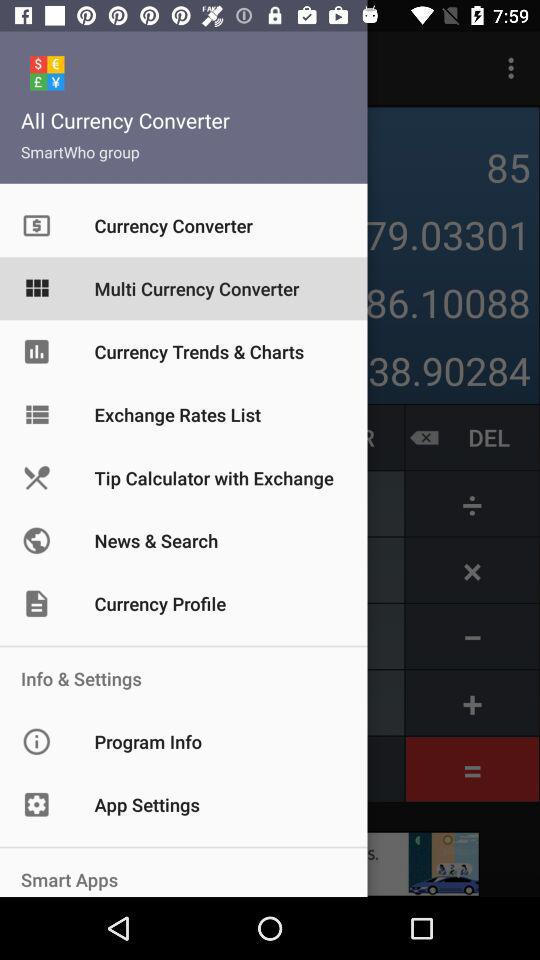Who is the developer of the application? The developer of the application is SmartWho. 